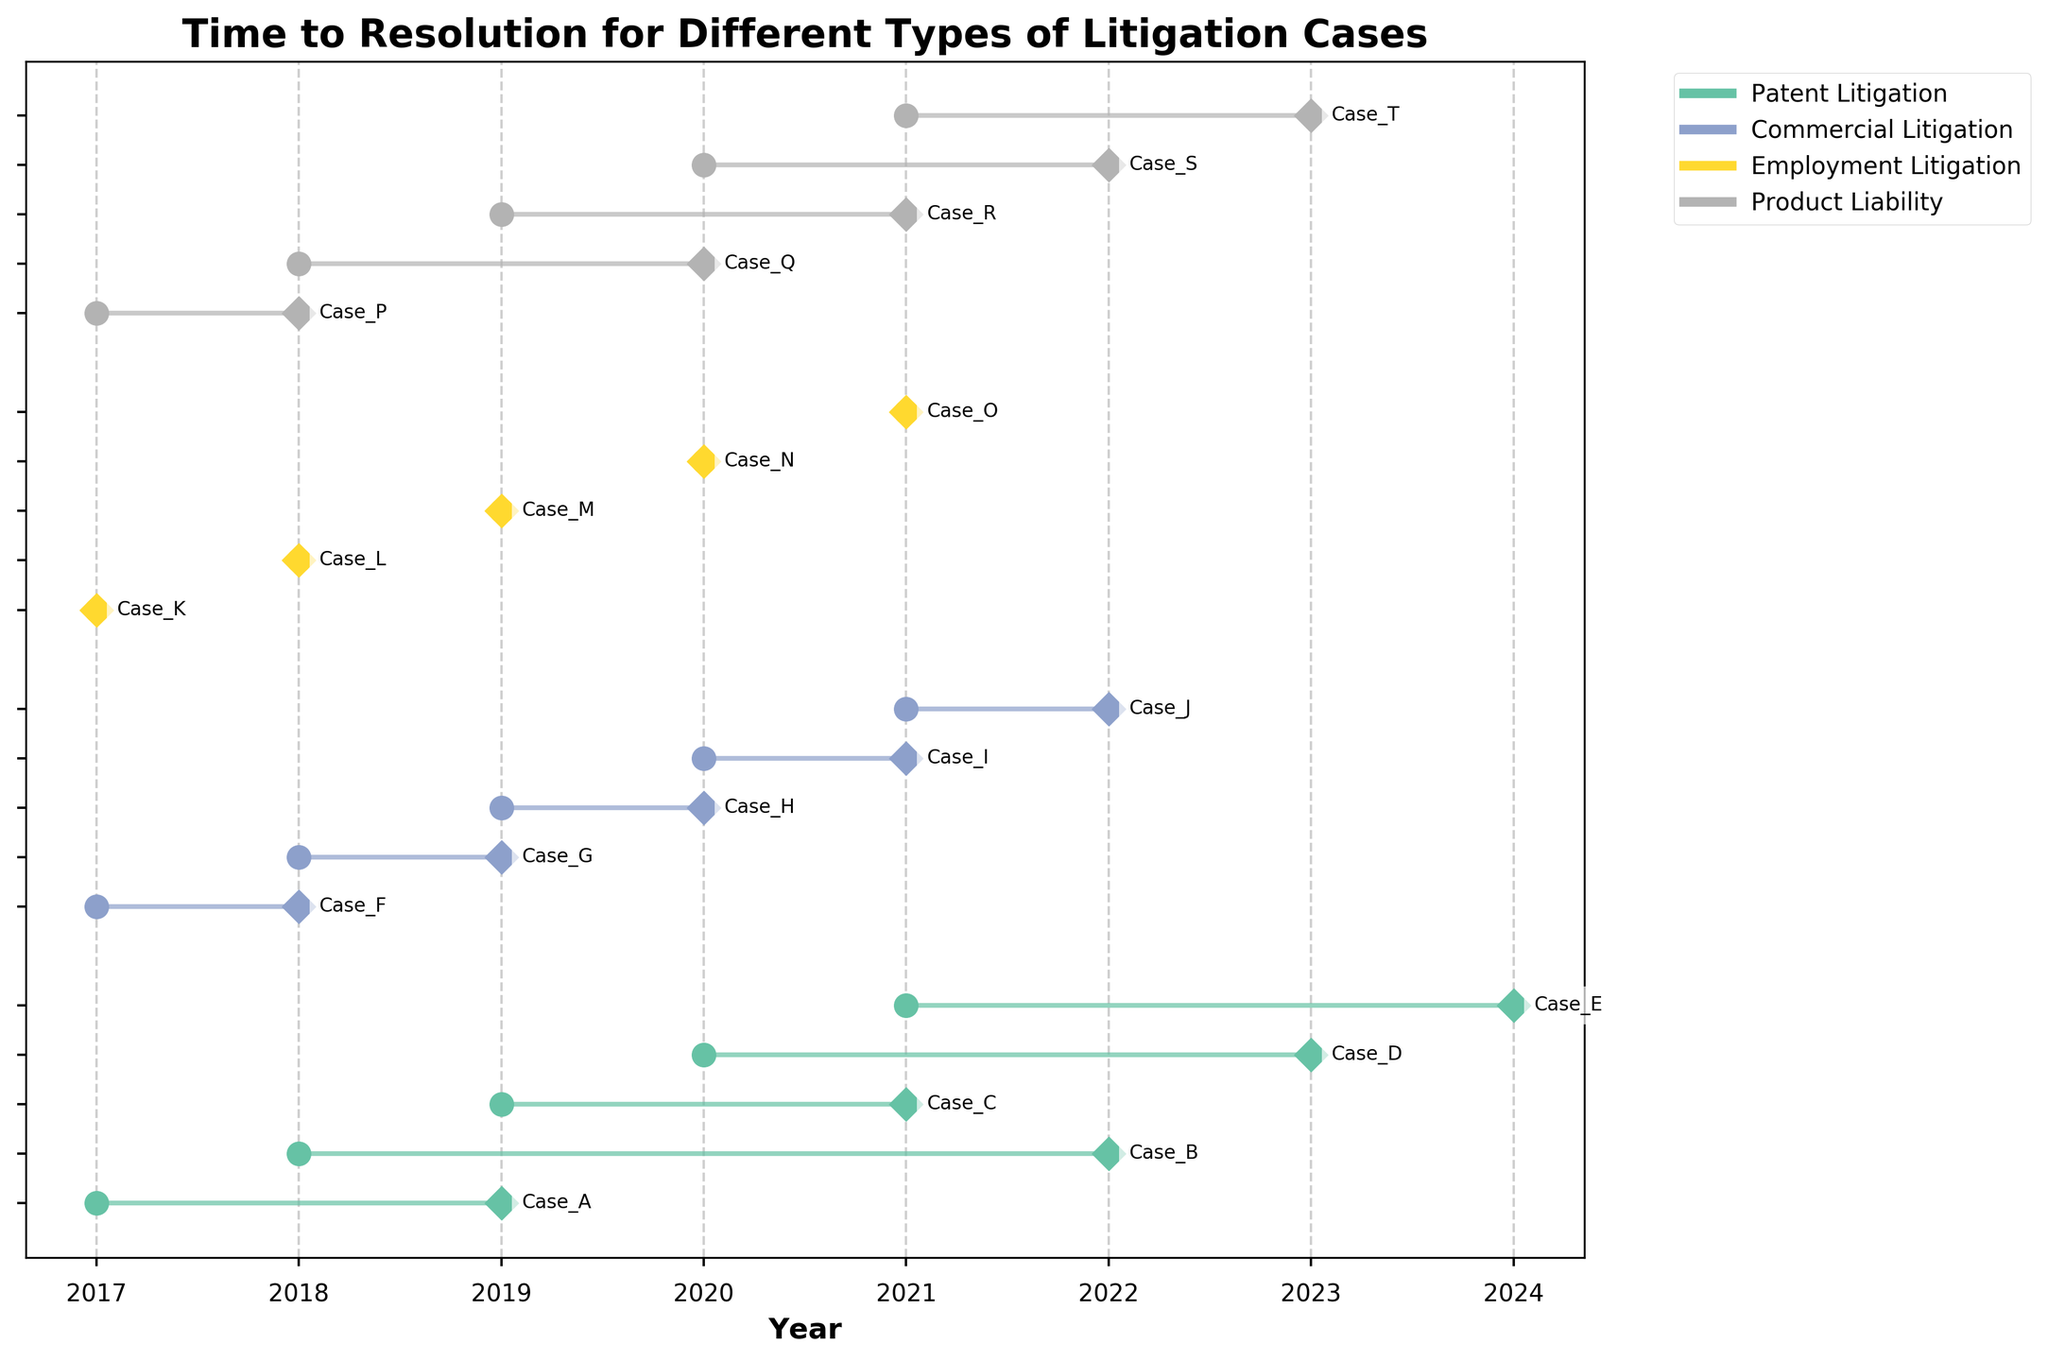What is the title of the plot? The title of the plot is displayed at the top center of the figure.
Answer: Time to Resolution for Different Types of Litigation Cases How many types of litigation cases are shown in the plot? There are multiple unique types of litigation cases, each shown in different colors. Count the distinct categories in the legend.
Answer: Four What is the horizontal axis labeled as? The horizontal axis label describes the unit of measurement for the x-axis. It is typically found beneath the thick horizontal line.
Answer: Year Which type of litigation case has the longest duration in a single case? Identify the case with the maximum difference between its end year and start year by visually examining the lines in the plot.
Answer: Patent Litigation For Patent Litigation cases, what is the average duration from start to end? Calculate the duration for each Patent Litigation case, sum these durations, and divide by the number of cases.
Answer: 3 years Which type of litigation case generally gets resolved the quickest? Compare the general length of the lines for each type of litigation case. Find the type with the shortest lines on average.
Answer: Employment Litigation What is the time span of Commercial Litigation cases? Identify the earliest start year and the latest end year for Commercial Litigation cases.
Answer: 2017 to 2022 Which product liability case took the longest to resolve? Look at the lines representing Product Liability cases and find the one with the greatest length.
Answer: Case_P How does the average duration of Product Liability cases compare to Commercial Litigation cases? Compute the average duration for each type by summing their durations and dividing by the number of cases, then compare the two averages.
Answer: Product Liability cases have a longer average duration 